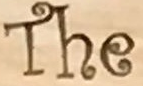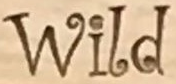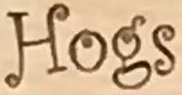What words are shown in these images in order, separated by a semicolon? The; Wild; Hogs 